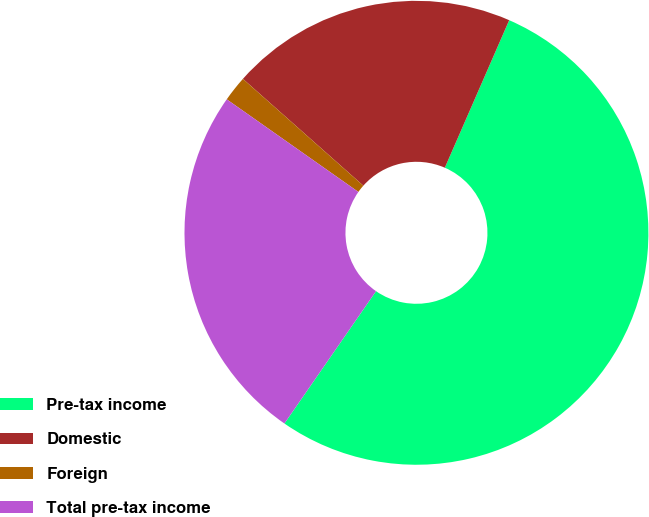<chart> <loc_0><loc_0><loc_500><loc_500><pie_chart><fcel>Pre-tax income<fcel>Domestic<fcel>Foreign<fcel>Total pre-tax income<nl><fcel>53.09%<fcel>20.0%<fcel>1.79%<fcel>25.12%<nl></chart> 